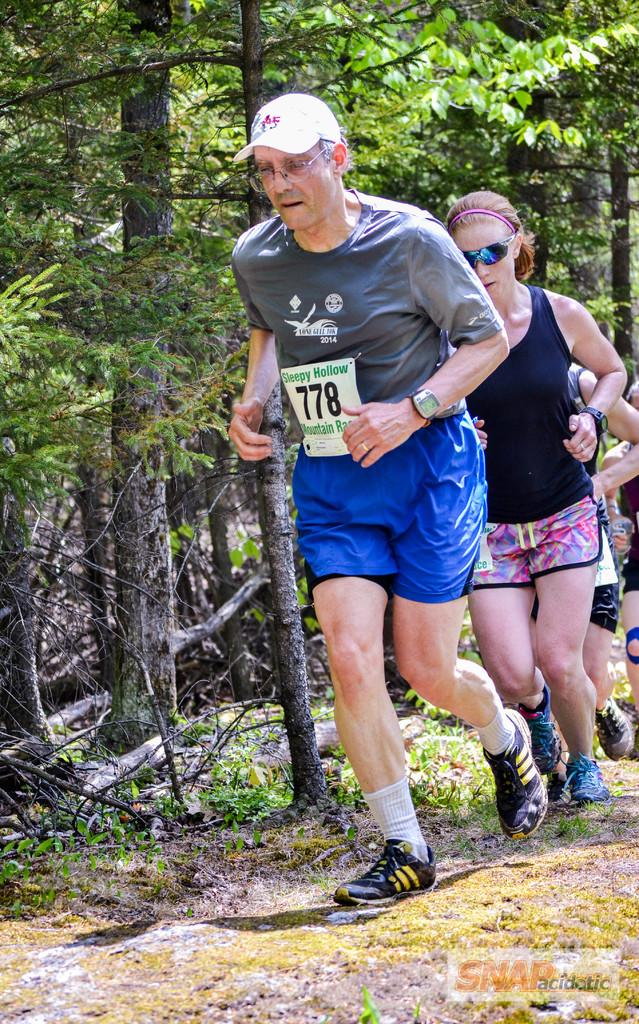What are the people in the image doing? The people in the image are running. What can be seen in the background of the image? There are trees in the image. Can you describe the accessories worn by any of the people in the image? One person is wearing sunglasses, and another person is wearing a cap. What type of wren can be seen perched on the person's shoulder in the image? There is no wren present in the image; it features people running with no birds visible. How many worms are visible on the ground in the image? There are no worms visible on the ground in the image. 